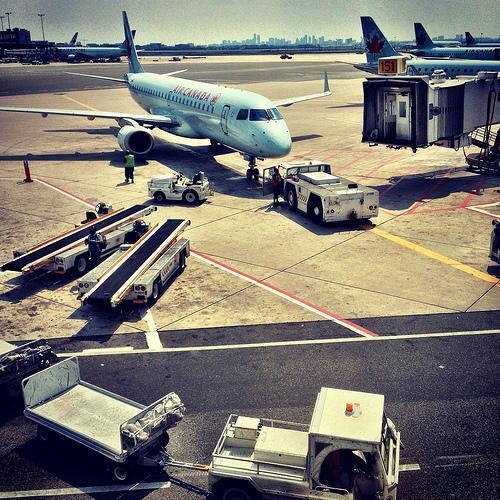How many wings does the plane have?
Give a very brief answer. 2. 